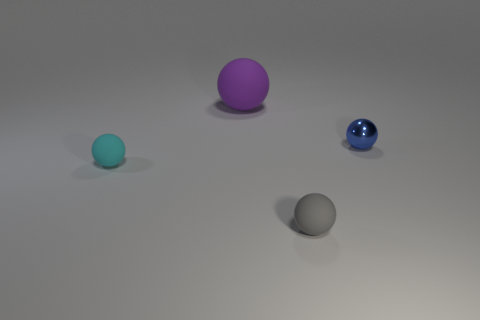There is a large ball that is the same material as the small gray ball; what is its color?
Your answer should be compact. Purple. What number of gray objects are spheres or large matte things?
Offer a very short reply. 1. Are there more small shiny objects than green matte things?
Your answer should be very brief. Yes. What number of objects are tiny balls that are on the right side of the large rubber thing or balls on the left side of the small shiny thing?
Your answer should be compact. 4. There is a rubber sphere that is the same size as the cyan thing; what color is it?
Ensure brevity in your answer.  Gray. Do the tiny cyan thing and the tiny blue sphere have the same material?
Offer a terse response. No. What is the material of the tiny object on the right side of the rubber object that is in front of the small cyan matte object?
Your answer should be compact. Metal. Is the number of tiny gray objects that are on the right side of the large matte ball greater than the number of blue shiny balls?
Ensure brevity in your answer.  No. How many other objects are there of the same size as the purple ball?
Your answer should be compact. 0. Do the big ball and the metallic object have the same color?
Make the answer very short. No. 